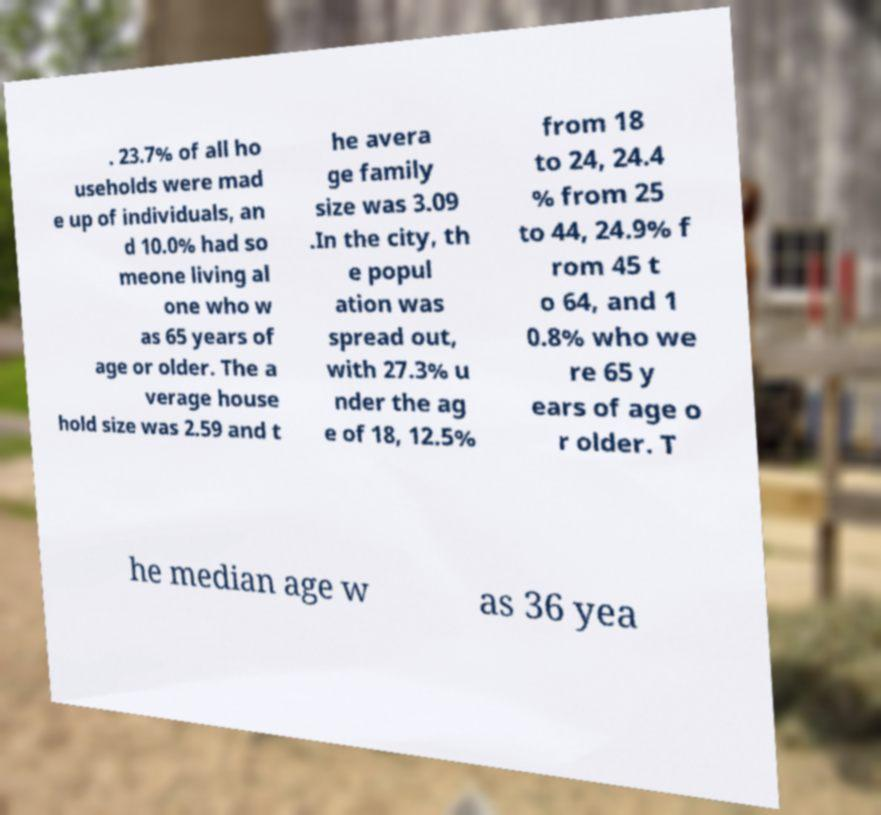I need the written content from this picture converted into text. Can you do that? . 23.7% of all ho useholds were mad e up of individuals, an d 10.0% had so meone living al one who w as 65 years of age or older. The a verage house hold size was 2.59 and t he avera ge family size was 3.09 .In the city, th e popul ation was spread out, with 27.3% u nder the ag e of 18, 12.5% from 18 to 24, 24.4 % from 25 to 44, 24.9% f rom 45 t o 64, and 1 0.8% who we re 65 y ears of age o r older. T he median age w as 36 yea 